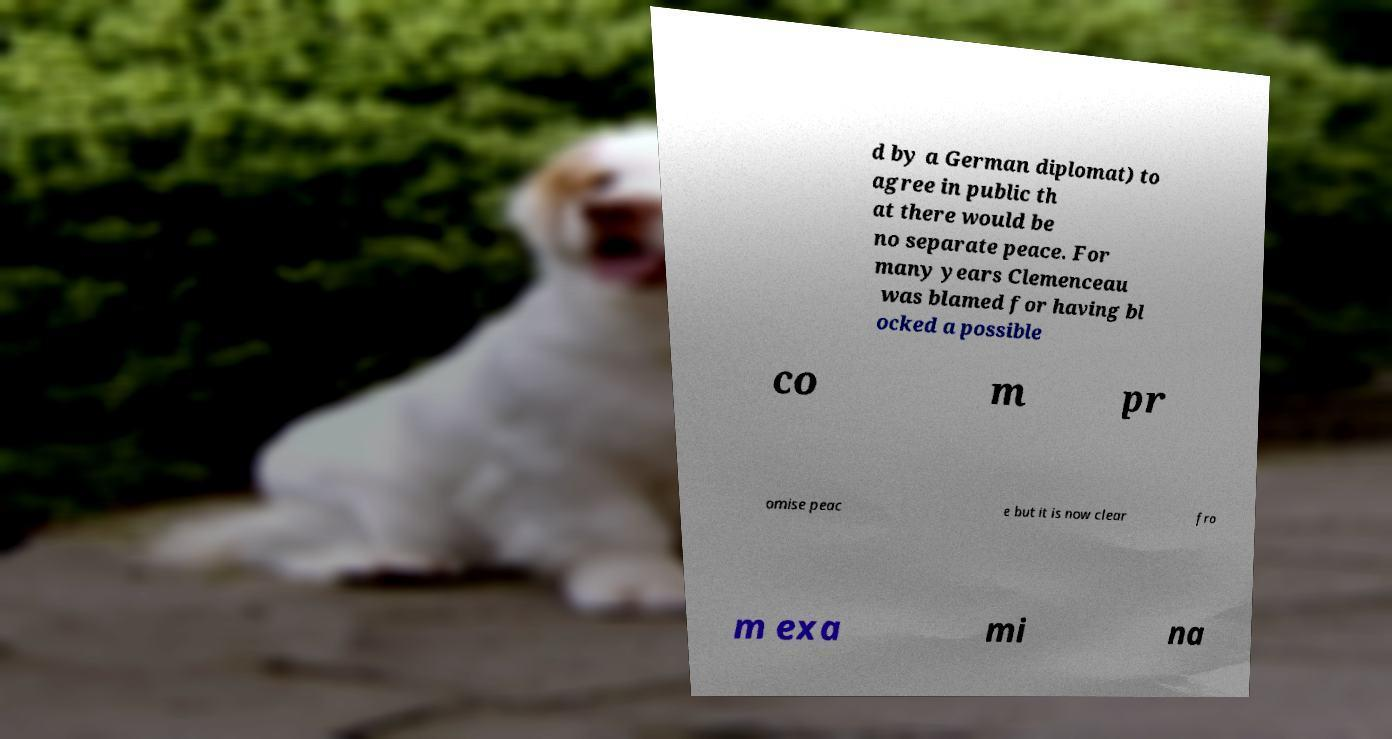I need the written content from this picture converted into text. Can you do that? d by a German diplomat) to agree in public th at there would be no separate peace. For many years Clemenceau was blamed for having bl ocked a possible co m pr omise peac e but it is now clear fro m exa mi na 